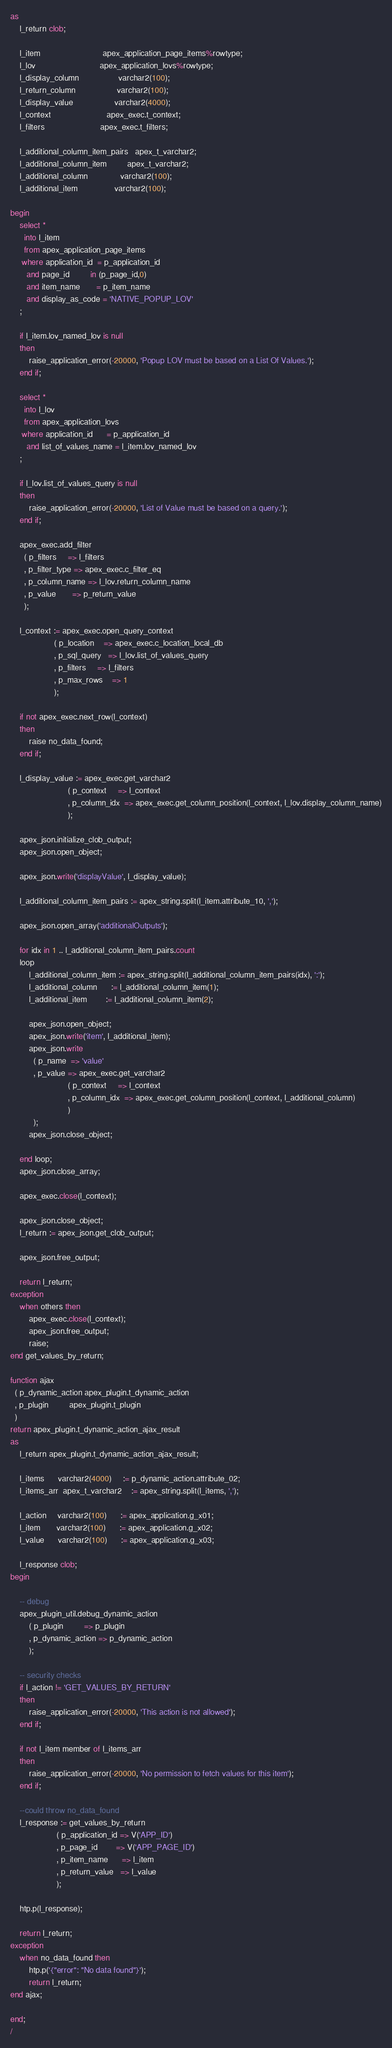Convert code to text. <code><loc_0><loc_0><loc_500><loc_500><_SQL_>as
    l_return clob;

    l_item                           apex_application_page_items%rowtype;
    l_lov                            apex_application_lovs%rowtype;
    l_display_column                 varchar2(100);
    l_return_column                  varchar2(100);
    l_display_value                  varchar2(4000);
    l_context                        apex_exec.t_context;
    l_filters                        apex_exec.t_filters;

    l_additional_column_item_pairs   apex_t_varchar2;
    l_additional_column_item         apex_t_varchar2;
    l_additional_column              varchar2(100);
    l_additional_item                varchar2(100);

begin
    select *
      into l_item
      from apex_application_page_items
     where application_id  = p_application_id
       and page_id         in (p_page_id,0)
       and item_name       = p_item_name
       and display_as_code = 'NATIVE_POPUP_LOV'
    ;

    if l_item.lov_named_lov is null
    then
        raise_application_error(-20000, 'Popup LOV must be based on a List Of Values.');
    end if;

    select *
      into l_lov
      from apex_application_lovs
     where application_id      = p_application_id
       and list_of_values_name = l_item.lov_named_lov
    ;

    if l_lov.list_of_values_query is null
    then
        raise_application_error(-20000, 'List of Value must be based on a query.');
    end if;

    apex_exec.add_filter
      ( p_filters     => l_filters
      , p_filter_type => apex_exec.c_filter_eq
      , p_column_name => l_lov.return_column_name
      , p_value       => p_return_value
      );

    l_context := apex_exec.open_query_context
                   ( p_location    => apex_exec.c_location_local_db
                   , p_sql_query   => l_lov.list_of_values_query
                   , p_filters     => l_filters
                   , p_max_rows    => 1
                   );

    if not apex_exec.next_row(l_context)
    then
        raise no_data_found;
    end if;

    l_display_value := apex_exec.get_varchar2
                         ( p_context     => l_context
                         , p_column_idx  => apex_exec.get_column_position(l_context, l_lov.display_column_name)
                         );

    apex_json.initialize_clob_output;
    apex_json.open_object;

    apex_json.write('displayValue', l_display_value);

    l_additional_column_item_pairs := apex_string.split(l_item.attribute_10, ',');

    apex_json.open_array('additionalOutputs');

    for idx in 1 .. l_additional_column_item_pairs.count
    loop
        l_additional_column_item := apex_string.split(l_additional_column_item_pairs(idx), ':');
        l_additional_column      := l_additional_column_item(1);
        l_additional_item        := l_additional_column_item(2);

        apex_json.open_object;
        apex_json.write('item', l_additional_item);
        apex_json.write
          ( p_name  => 'value'
          , p_value => apex_exec.get_varchar2
                         ( p_context     => l_context
                         , p_column_idx  => apex_exec.get_column_position(l_context, l_additional_column)
                         )
          );
        apex_json.close_object;

    end loop;
    apex_json.close_array;

    apex_exec.close(l_context);

    apex_json.close_object;
    l_return := apex_json.get_clob_output;

    apex_json.free_output;

    return l_return;
exception
    when others then
        apex_exec.close(l_context);
        apex_json.free_output;
        raise;
end get_values_by_return;

function ajax
  ( p_dynamic_action apex_plugin.t_dynamic_action
  , p_plugin         apex_plugin.t_plugin
  )
return apex_plugin.t_dynamic_action_ajax_result
as
    l_return apex_plugin.t_dynamic_action_ajax_result;

    l_items      varchar2(4000)     := p_dynamic_action.attribute_02;
    l_items_arr  apex_t_varchar2    := apex_string.split(l_items, ',');

    l_action     varchar2(100)      := apex_application.g_x01;
    l_item       varchar2(100)      := apex_application.g_x02;
    l_value      varchar2(100)      := apex_application.g_x03;

    l_response clob;
begin

    -- debug
    apex_plugin_util.debug_dynamic_action
        ( p_plugin         => p_plugin
        , p_dynamic_action => p_dynamic_action
        );

    -- security checks
    if l_action != 'GET_VALUES_BY_RETURN'
    then
        raise_application_error(-20000, 'This action is not allowed');
    end if;

    if not l_item member of l_items_arr
    then
        raise_application_error(-20000, 'No permission to fetch values for this item');
    end if;

    --could throw no_data_found
    l_response := get_values_by_return
                    ( p_application_id => V('APP_ID')
                    , p_page_id        => V('APP_PAGE_ID')
                    , p_item_name      => l_item
                    , p_return_value   => l_value
                    );

    htp.p(l_response);

    return l_return;
exception
    when no_data_found then
        htp.p('{"error": "No data found"}');
        return l_return;
end ajax;

end;
/


</code> 